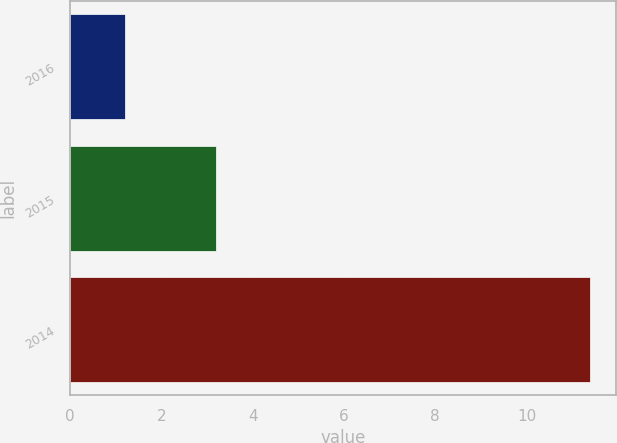Convert chart to OTSL. <chart><loc_0><loc_0><loc_500><loc_500><bar_chart><fcel>2016<fcel>2015<fcel>2014<nl><fcel>1.2<fcel>3.2<fcel>11.4<nl></chart> 